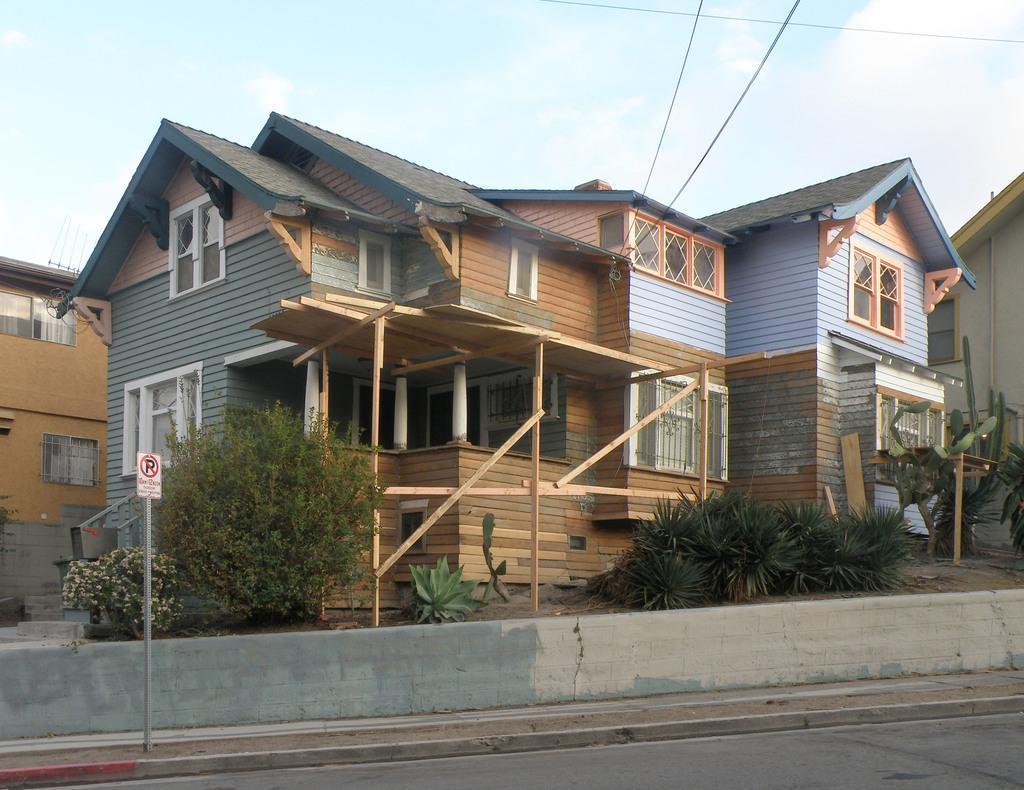In one or two sentences, can you explain what this image depicts? In the center of the image there are buildings. At the bottom there are plants and bushes. On the left there is a sign board. At the bottom we can see a road. In the background there are wires and sky. 